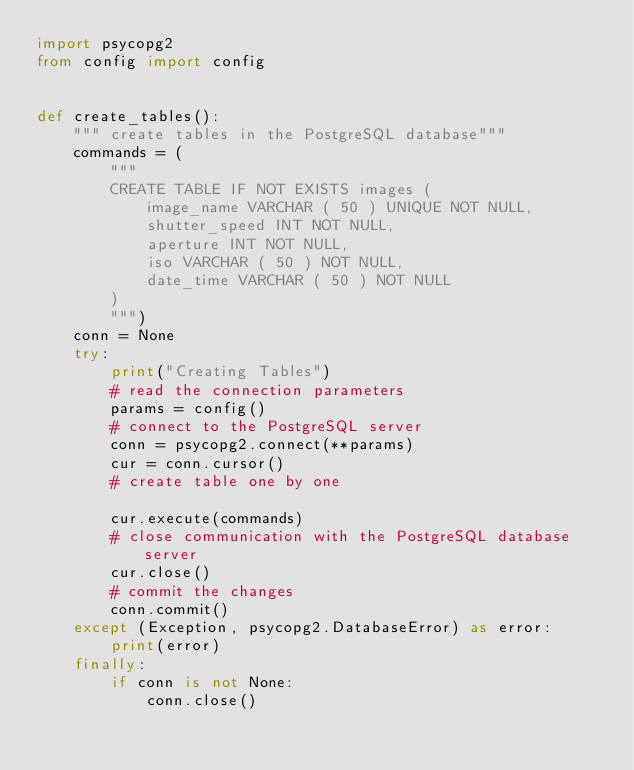<code> <loc_0><loc_0><loc_500><loc_500><_Python_>import psycopg2
from config import config


def create_tables():
    """ create tables in the PostgreSQL database"""
    commands = (
        """
        CREATE TABLE IF NOT EXISTS images (
            image_name VARCHAR ( 50 ) UNIQUE NOT NULL,
            shutter_speed INT NOT NULL,
            aperture INT NOT NULL,
            iso VARCHAR ( 50 ) NOT NULL,
            date_time VARCHAR ( 50 ) NOT NULL
        )
        """)
    conn = None
    try:
        print("Creating Tables")
        # read the connection parameters
        params = config()
        # connect to the PostgreSQL server
        conn = psycopg2.connect(**params)
        cur = conn.cursor()
        # create table one by one

        cur.execute(commands)
        # close communication with the PostgreSQL database server
        cur.close()
        # commit the changes
        conn.commit()
    except (Exception, psycopg2.DatabaseError) as error:
        print(error)
    finally:
        if conn is not None:
            conn.close()



</code> 